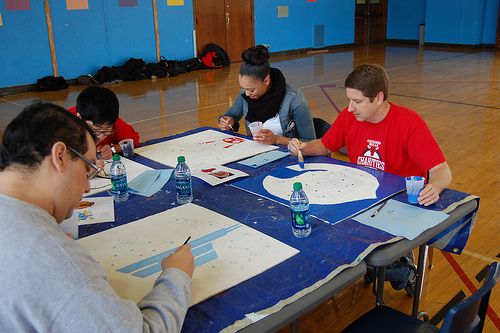<image>
Is there a paintbrush on the woman? No. The paintbrush is not positioned on the woman. They may be near each other, but the paintbrush is not supported by or resting on top of the woman. Where is the trash in relation to the man? Is it to the right of the man? No. The trash is not to the right of the man. The horizontal positioning shows a different relationship. 